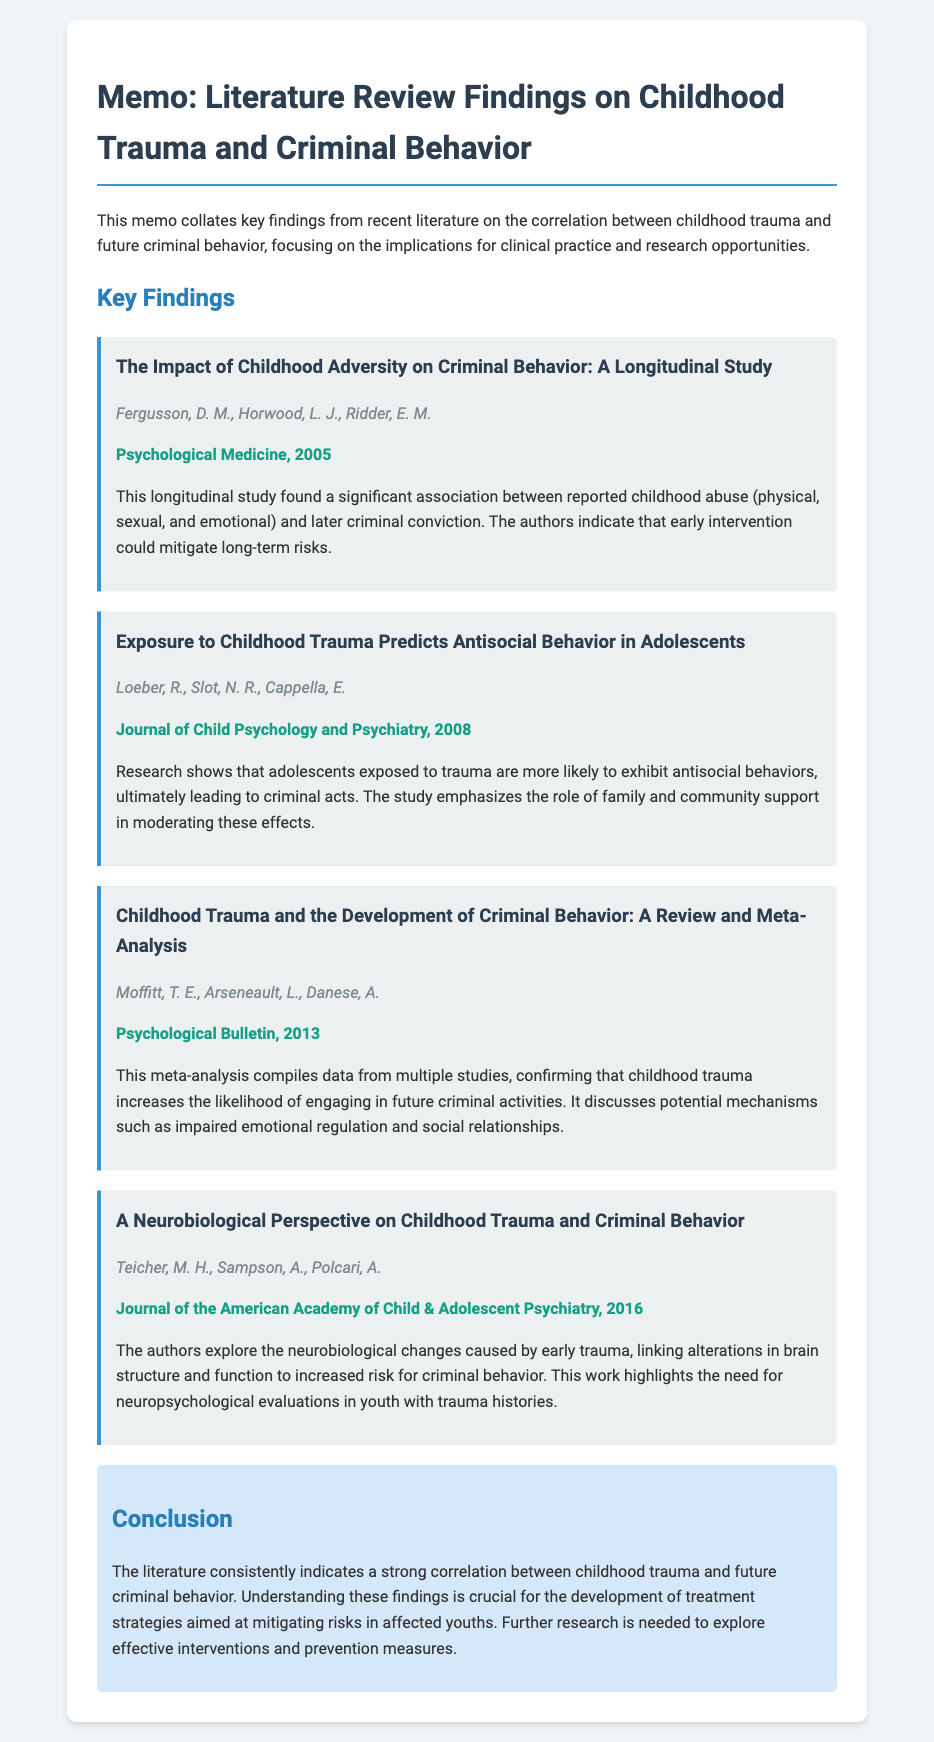what is the title of the memo? The title of the memo is presented at the top of the document, highlighting the main focus of the content.
Answer: Memo: Literature Review Findings on Childhood Trauma and Criminal Behavior who conducted the longitudinal study on childhood adversity? The authors of the longitudinal study are explicitly listed, providing the names of the researchers involved in the study.
Answer: Fergusson, D. M., Horwood, L. J., Ridder, E. M what year was the review and meta-analysis published? The publication year is included in the reference for the review and meta-analysis, ensuring proper citation and context of the research.
Answer: 2013 what is a key finding from Teicher et al.'s research? The document provides the main conclusion of the study, focusing on the implications of their findings regarding neurobiological changes.
Answer: Alterations in brain structure and function which journal published the study about trauma predicting antisocial behavior? The journal name is included after the authors' names, indicating where the research was formally presented.
Answer: Journal of Child Psychology and Psychiatry what common conclusion do the studies share? The final section summarizes the overall agreement among the research findings, emphasizing a significant relationship.
Answer: Strong correlation between childhood trauma and future criminal behavior how many key findings are discussed in the memo? The document outlines multiple findings, and counting these explicitly gives us a numerical answer regarding the research presented.
Answer: Four what is emphasized as a potential intervention for affected youths? The conclusion hints at future research directions and strategies, suggesting areas for clinical significance.
Answer: Treatment strategies 